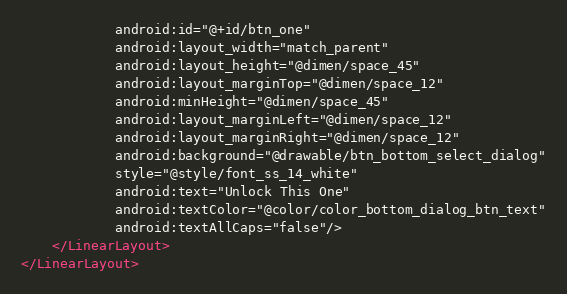Convert code to text. <code><loc_0><loc_0><loc_500><loc_500><_XML_>            android:id="@+id/btn_one"
            android:layout_width="match_parent"
            android:layout_height="@dimen/space_45"
            android:layout_marginTop="@dimen/space_12"
            android:minHeight="@dimen/space_45"
            android:layout_marginLeft="@dimen/space_12"
            android:layout_marginRight="@dimen/space_12"
            android:background="@drawable/btn_bottom_select_dialog"
            style="@style/font_ss_14_white"
            android:text="Unlock This One"
            android:textColor="@color/color_bottom_dialog_btn_text"
            android:textAllCaps="false"/>
    </LinearLayout>
</LinearLayout></code> 